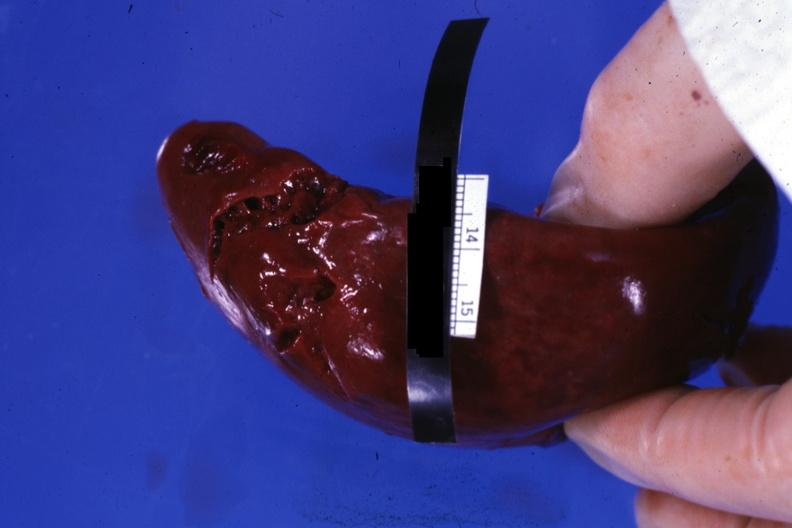does this image show external view of lacerations of capsule apparently done during surgical procedure?
Answer the question using a single word or phrase. Yes 